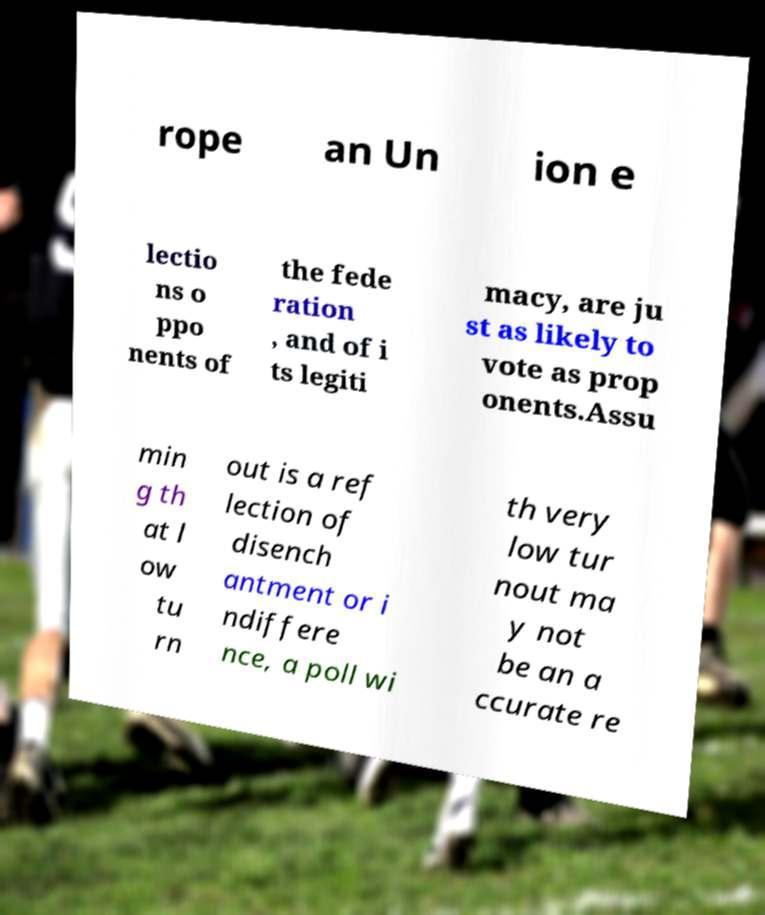What messages or text are displayed in this image? I need them in a readable, typed format. rope an Un ion e lectio ns o ppo nents of the fede ration , and of i ts legiti macy, are ju st as likely to vote as prop onents.Assu min g th at l ow tu rn out is a ref lection of disench antment or i ndiffere nce, a poll wi th very low tur nout ma y not be an a ccurate re 